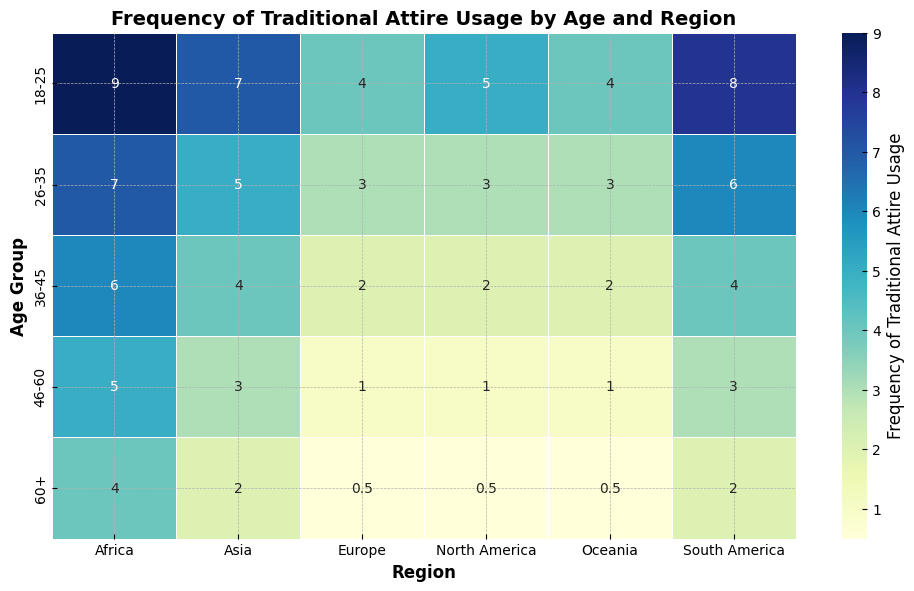Which region has the highest frequency of traditional attire usage among the 18-25 age group? To determine this, look at the row corresponding to the 18-25 age group and identify the region with the highest value.
Answer: Africa What is the difference in traditional attire usage frequency between the 26-35 and 46-60 age groups in Asia? Find the frequency values for the 26-35 and 46-60 age groups in Asia and subtract the latter from the former.
Answer: 2 In which age group does North America show the lowest frequency of traditional attire usage? Observe the frequencies for all age groups in North America and identify the one with the lowest value.
Answer: 60+ Which two regions have an equal frequency of traditional attire usage in the 60+ age group? Check the frequency values in the 60+ age group for different regions and identify the ones that are equal.
Answer: North America and Europe What is the average frequency of traditional attire usage for the 36-45 age group across all regions? Sum the frequency values for the 36-45 age group in all regions and divide by the number of regions.
Answer: 3.33 Which age group shows the highest variation in traditional attire usage frequency across different regions? Compare the range (difference between highest and lowest values) of attire usage frequencies across all age groups and determine which has the highest variation.
Answer: 18-25 Is the frequency of traditional attire usage in Africa for the 46-60 age group higher or lower than in South America for the same age group? Compare the frequency values for the 46-60 age group between Africa and South America.
Answer: Higher What is the sum of the frequencies of traditional attire usage in Europe for all age groups combined? Add the frequency values for all age groups in Europe.
Answer: 10 